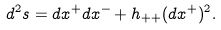Convert formula to latex. <formula><loc_0><loc_0><loc_500><loc_500>d ^ { 2 } s = d x ^ { + } d x ^ { - } + h _ { + + } ( d x ^ { + } ) ^ { 2 } .</formula> 